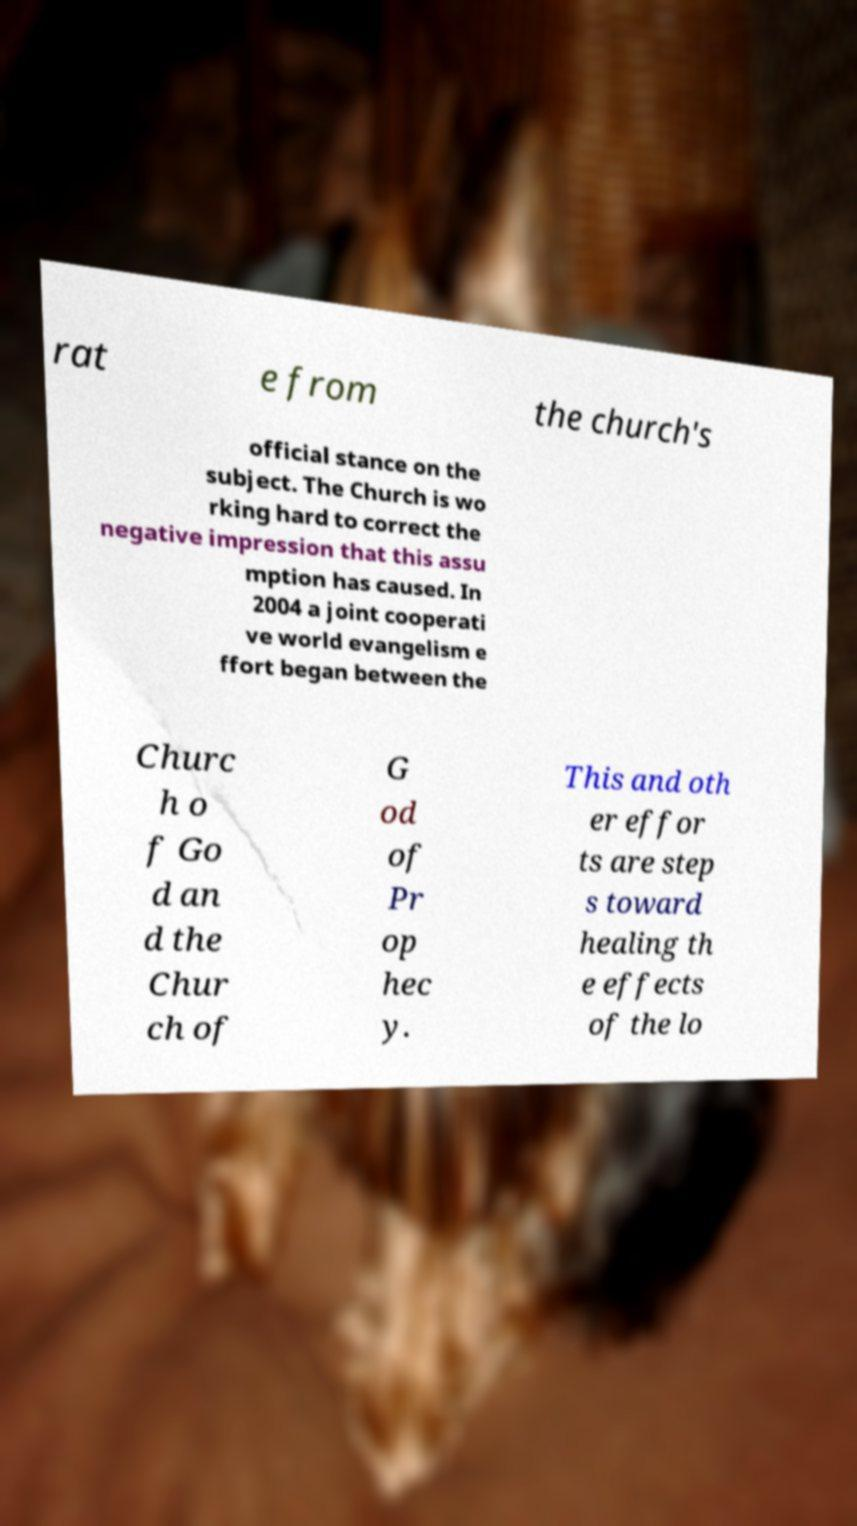Can you accurately transcribe the text from the provided image for me? rat e from the church's official stance on the subject. The Church is wo rking hard to correct the negative impression that this assu mption has caused. In 2004 a joint cooperati ve world evangelism e ffort began between the Churc h o f Go d an d the Chur ch of G od of Pr op hec y. This and oth er effor ts are step s toward healing th e effects of the lo 